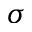Convert formula to latex. <formula><loc_0><loc_0><loc_500><loc_500>\sigma</formula> 